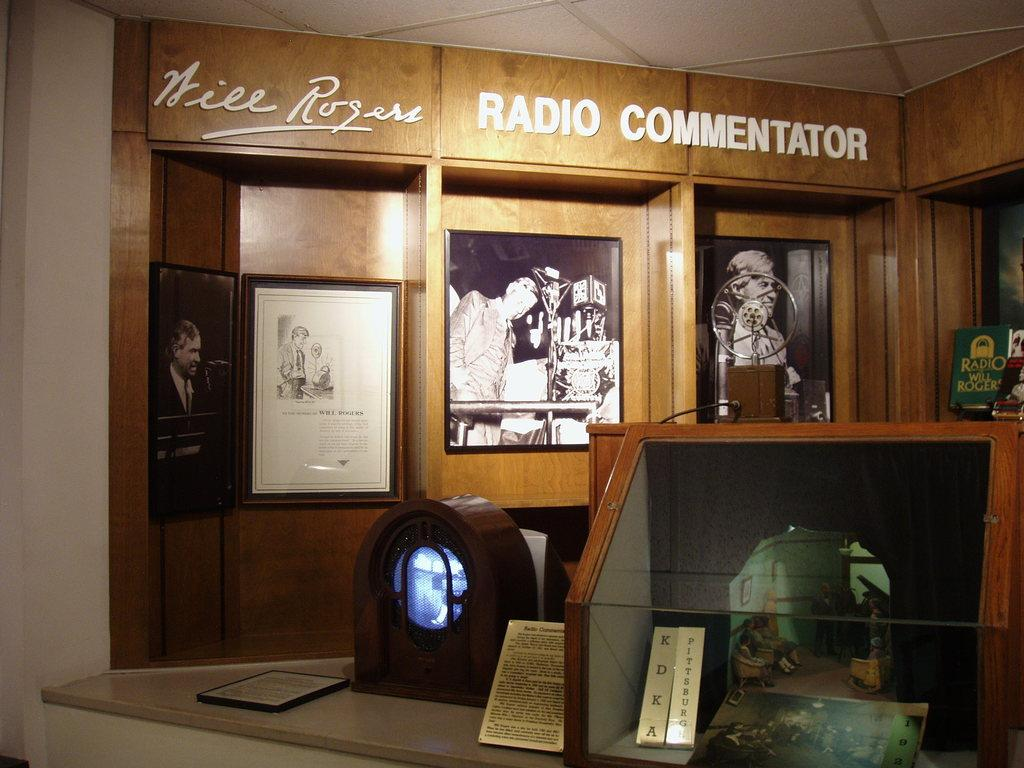<image>
Provide a brief description of the given image. a wall covered with framed trophies and pictures with the words radio commentator on the top. 